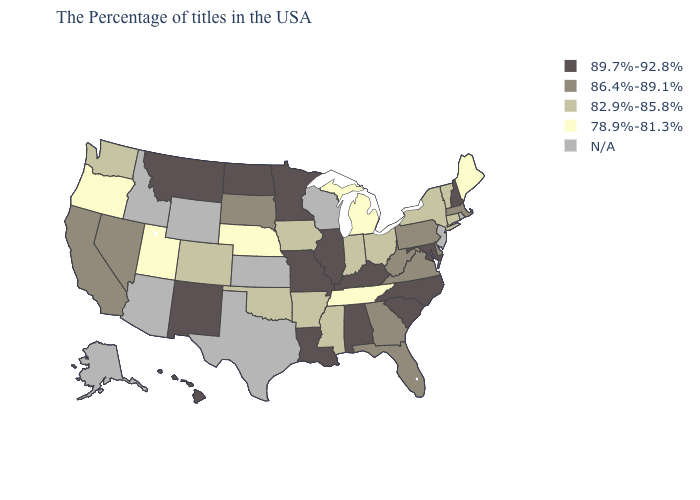What is the highest value in states that border Illinois?
Quick response, please. 89.7%-92.8%. What is the value of Connecticut?
Be succinct. 82.9%-85.8%. Name the states that have a value in the range 82.9%-85.8%?
Give a very brief answer. Vermont, Connecticut, New York, Ohio, Indiana, Mississippi, Arkansas, Iowa, Oklahoma, Colorado, Washington. Name the states that have a value in the range 86.4%-89.1%?
Short answer required. Massachusetts, Delaware, Pennsylvania, Virginia, West Virginia, Florida, Georgia, South Dakota, Nevada, California. Does Maryland have the lowest value in the USA?
Be succinct. No. Is the legend a continuous bar?
Quick response, please. No. What is the highest value in the West ?
Write a very short answer. 89.7%-92.8%. Name the states that have a value in the range N/A?
Keep it brief. Rhode Island, New Jersey, Wisconsin, Kansas, Texas, Wyoming, Arizona, Idaho, Alaska. Does Oregon have the lowest value in the USA?
Give a very brief answer. Yes. Among the states that border Vermont , which have the highest value?
Concise answer only. New Hampshire. What is the value of Alaska?
Short answer required. N/A. Among the states that border Wyoming , which have the highest value?
Quick response, please. Montana. 